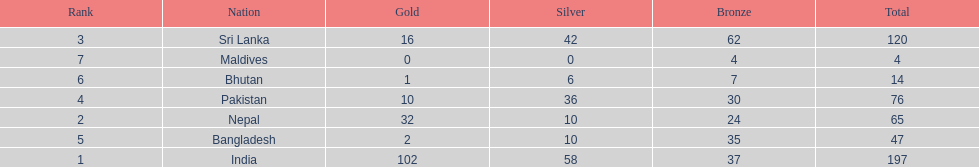Who has won the most bronze medals? Sri Lanka. 